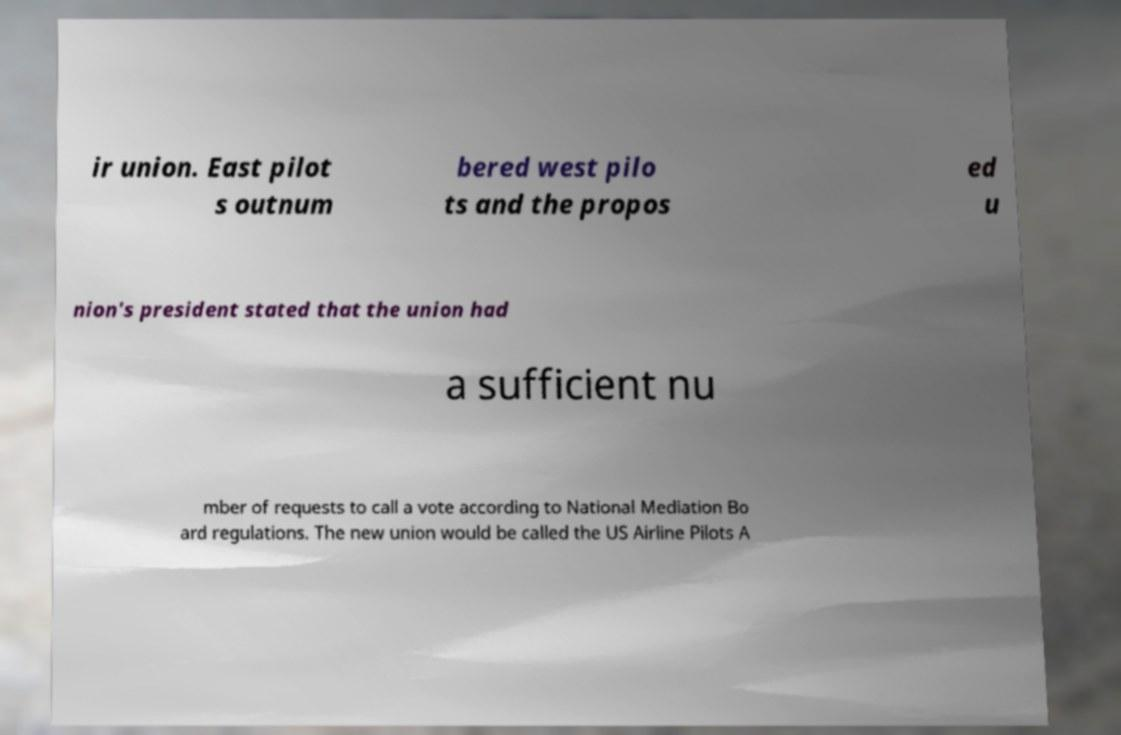What messages or text are displayed in this image? I need them in a readable, typed format. ir union. East pilot s outnum bered west pilo ts and the propos ed u nion's president stated that the union had a sufficient nu mber of requests to call a vote according to National Mediation Bo ard regulations. The new union would be called the US Airline Pilots A 